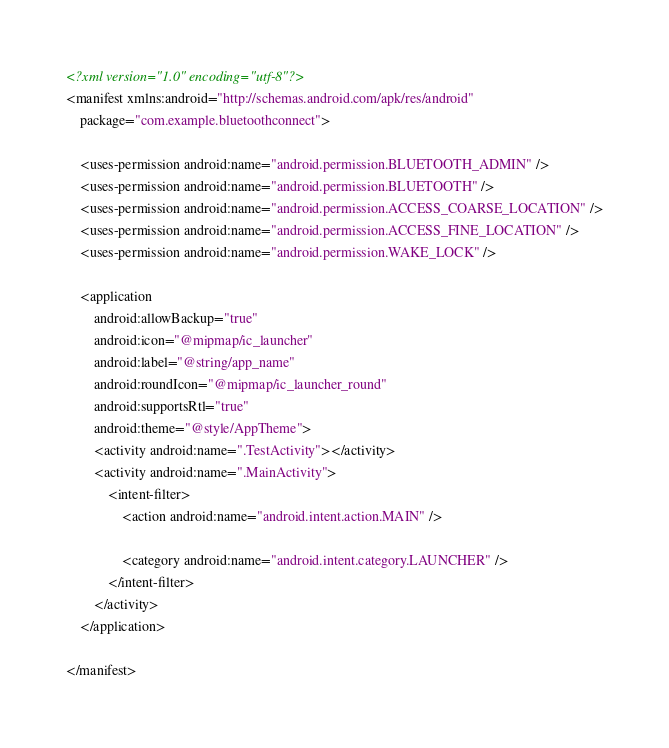Convert code to text. <code><loc_0><loc_0><loc_500><loc_500><_XML_><?xml version="1.0" encoding="utf-8"?>
<manifest xmlns:android="http://schemas.android.com/apk/res/android"
    package="com.example.bluetoothconnect">

    <uses-permission android:name="android.permission.BLUETOOTH_ADMIN" />
    <uses-permission android:name="android.permission.BLUETOOTH" />
    <uses-permission android:name="android.permission.ACCESS_COARSE_LOCATION" />
    <uses-permission android:name="android.permission.ACCESS_FINE_LOCATION" />
    <uses-permission android:name="android.permission.WAKE_LOCK" />

    <application
        android:allowBackup="true"
        android:icon="@mipmap/ic_launcher"
        android:label="@string/app_name"
        android:roundIcon="@mipmap/ic_launcher_round"
        android:supportsRtl="true"
        android:theme="@style/AppTheme">
        <activity android:name=".TestActivity"></activity>
        <activity android:name=".MainActivity">
            <intent-filter>
                <action android:name="android.intent.action.MAIN" />

                <category android:name="android.intent.category.LAUNCHER" />
            </intent-filter>
        </activity>
    </application>

</manifest></code> 